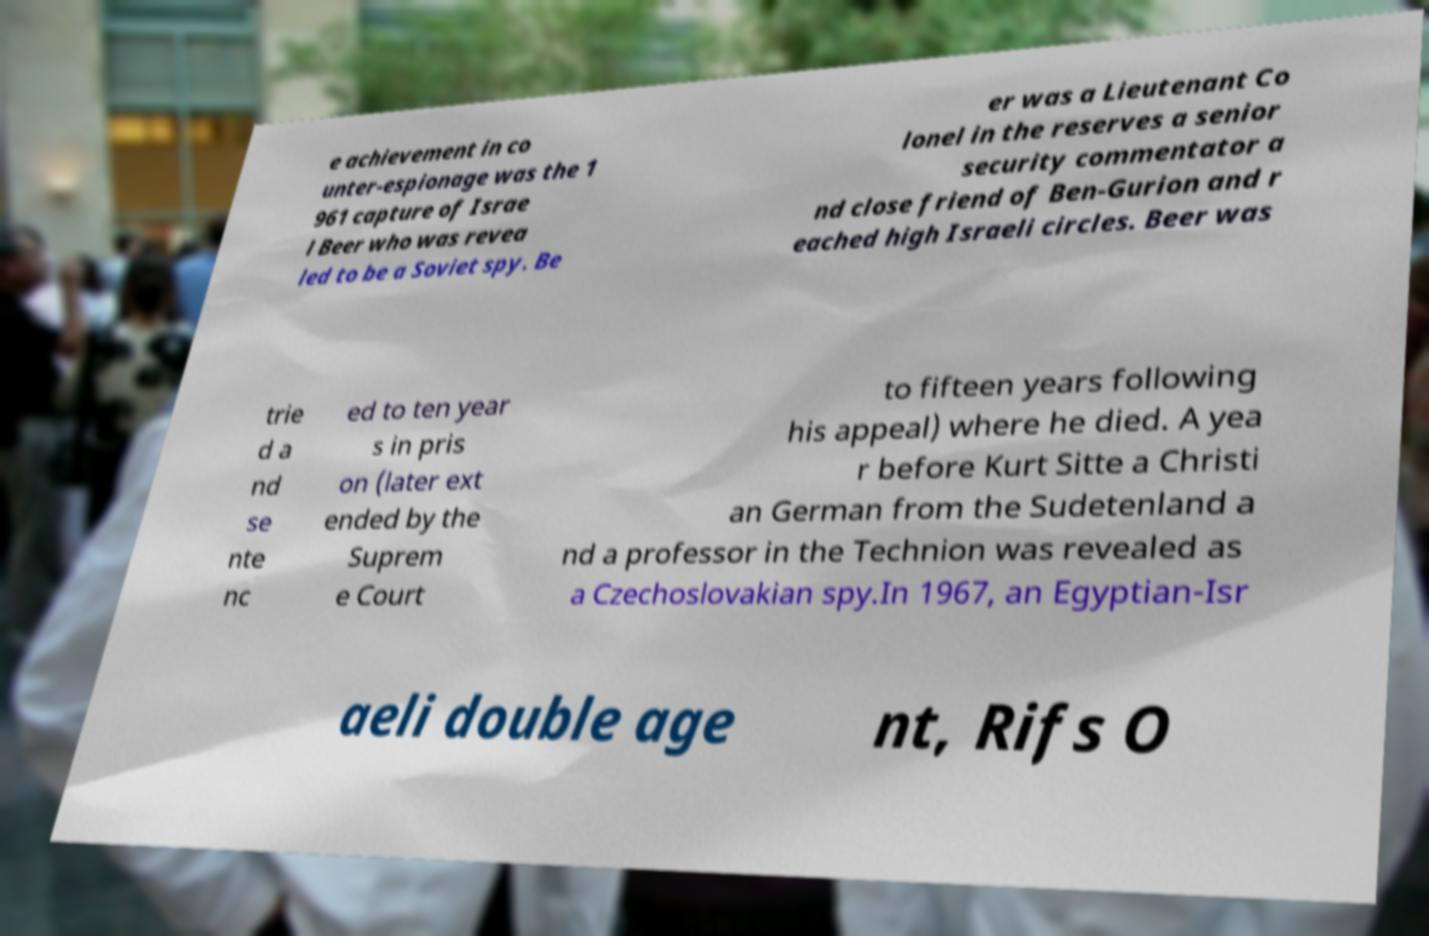Could you assist in decoding the text presented in this image and type it out clearly? e achievement in co unter-espionage was the 1 961 capture of Israe l Beer who was revea led to be a Soviet spy. Be er was a Lieutenant Co lonel in the reserves a senior security commentator a nd close friend of Ben-Gurion and r eached high Israeli circles. Beer was trie d a nd se nte nc ed to ten year s in pris on (later ext ended by the Suprem e Court to fifteen years following his appeal) where he died. A yea r before Kurt Sitte a Christi an German from the Sudetenland a nd a professor in the Technion was revealed as a Czechoslovakian spy.In 1967, an Egyptian-Isr aeli double age nt, Rifs O 